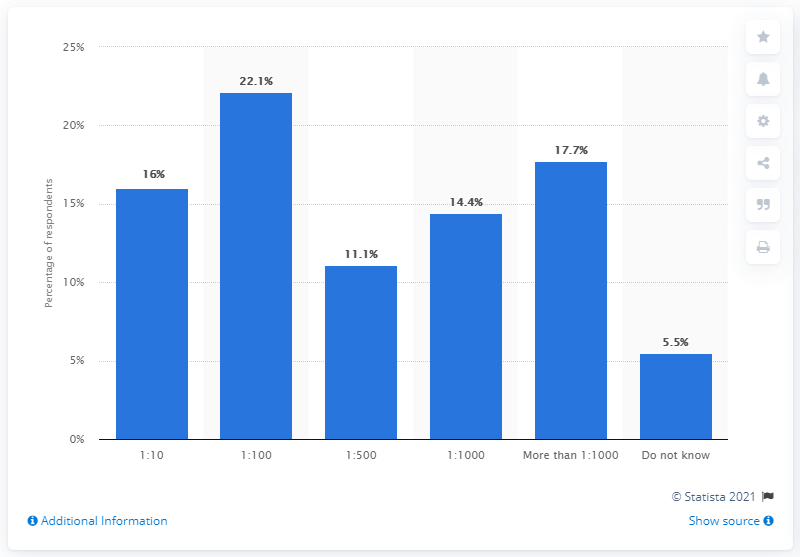Specify some key components in this picture. Approximately 11.1% of respondents reported that their organizations have one cyber security staff member for every 500 IT users. 